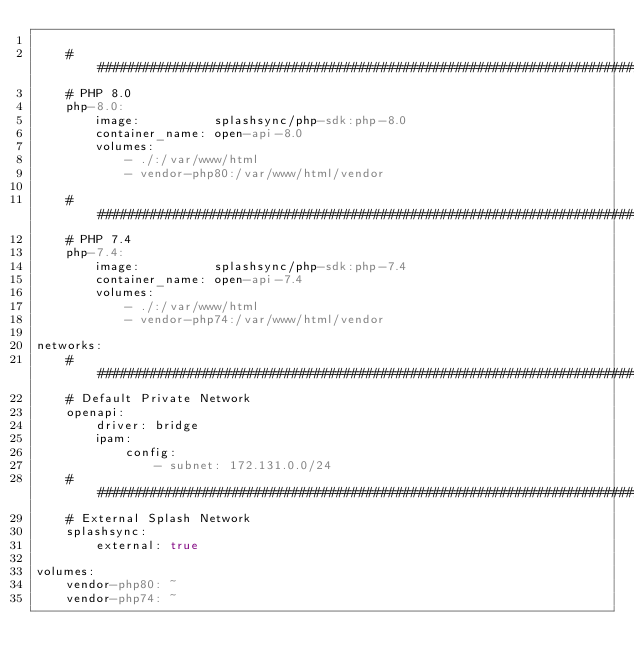<code> <loc_0><loc_0><loc_500><loc_500><_YAML_>
    ################################################################################
    # PHP 8.0
    php-8.0:
        image:          splashsync/php-sdk:php-8.0
        container_name: open-api-8.0
        volumes:
            - ./:/var/www/html
            - vendor-php80:/var/www/html/vendor

    ################################################################################
    # PHP 7.4
    php-7.4:
        image:          splashsync/php-sdk:php-7.4
        container_name: open-api-7.4
        volumes:
            - ./:/var/www/html
            - vendor-php74:/var/www/html/vendor

networks:
    ################################################################################
    # Default Private Network    
    openapi:
        driver: bridge
        ipam:
            config:
                - subnet: 172.131.0.0/24
    ################################################################################
    # External Splash Network
    splashsync:
        external: true

volumes:
    vendor-php80: ~
    vendor-php74: ~</code> 